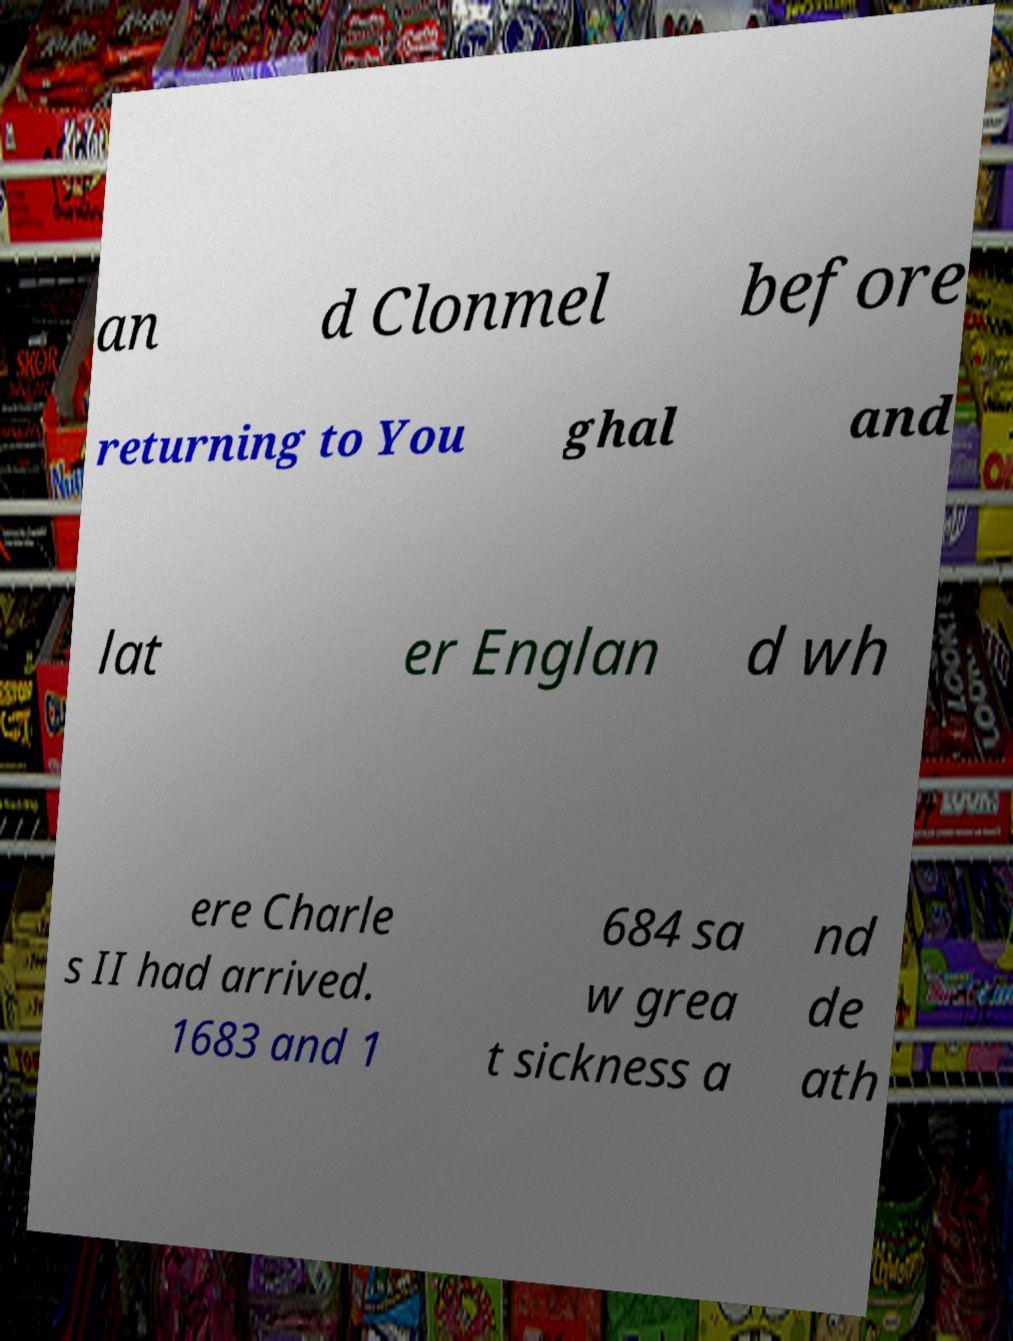There's text embedded in this image that I need extracted. Can you transcribe it verbatim? an d Clonmel before returning to You ghal and lat er Englan d wh ere Charle s II had arrived. 1683 and 1 684 sa w grea t sickness a nd de ath 